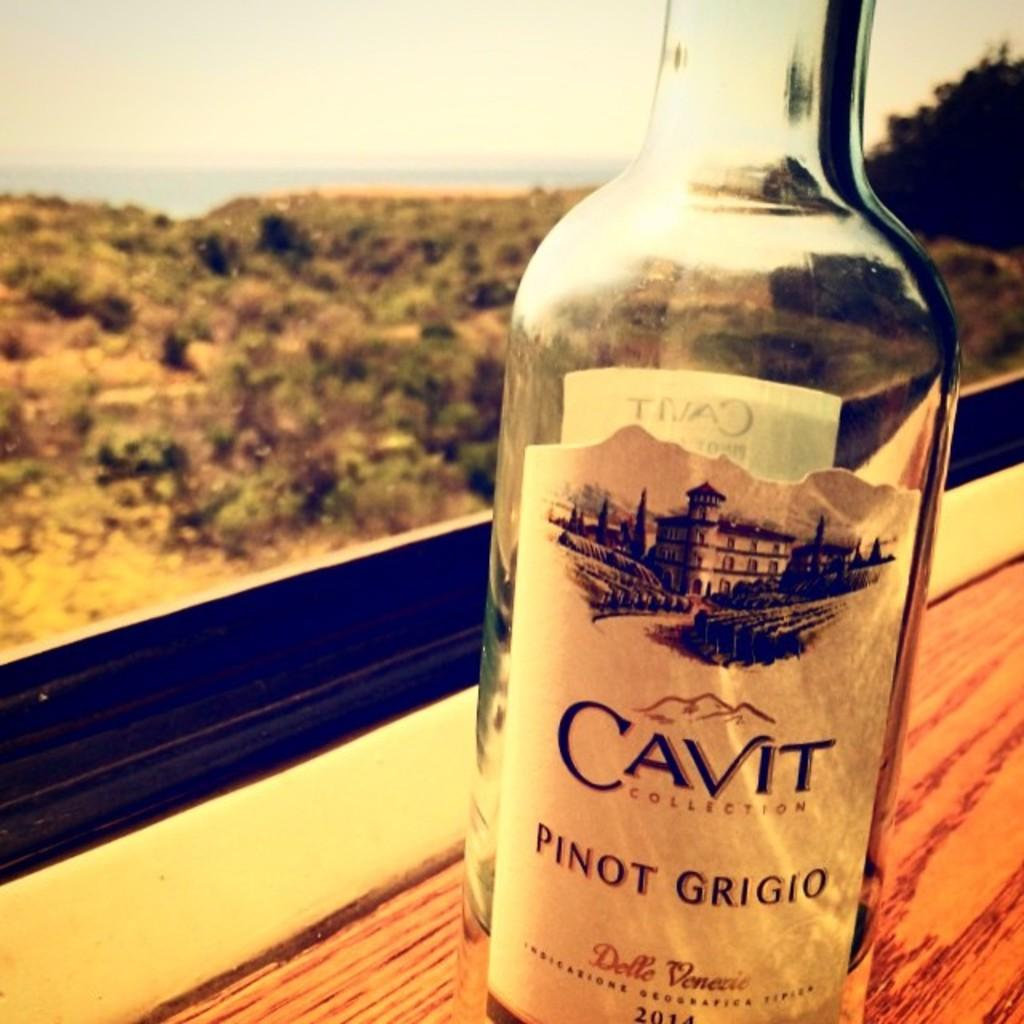<image>
Relay a brief, clear account of the picture shown. the word cavit is on a wine bottle 